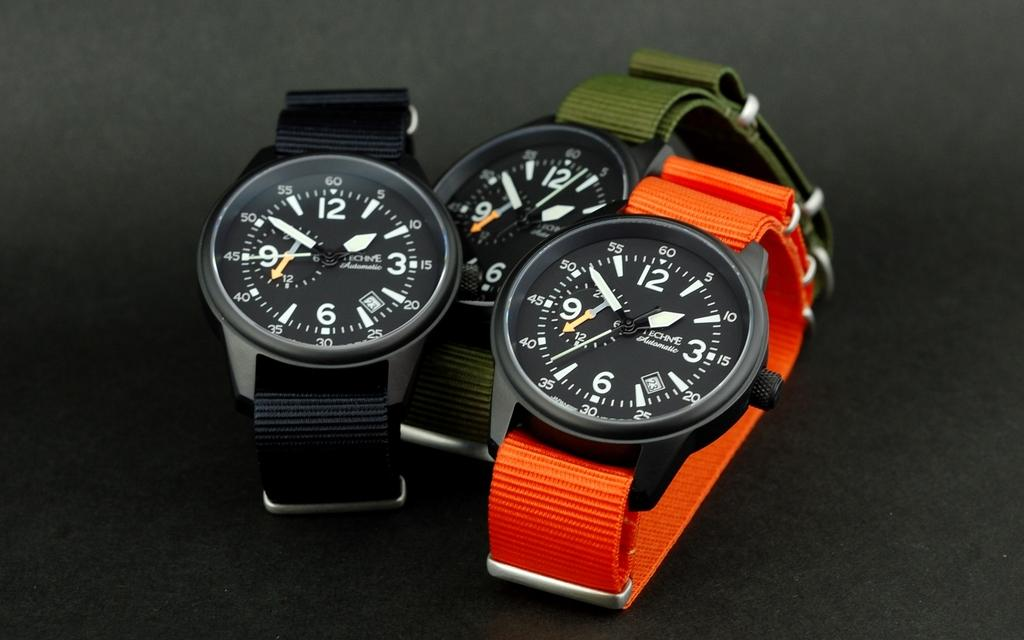How many watches are visible in the image? There are three watches in the image. What distinguishes the watches from one another? The watches have different colors. What can be seen on the faces of the watches? The watches have numbers on their faces. What features are present on the watches for measuring time? The watches have hour, minute, and second hands. What is the color of the background in the image? The background of the image is black. What type of weather condition is depicted in the image? There is no weather condition depicted in the image; it features three watches with a black background. What sound can be heard coming from the watches in the image? There is no sound coming from the watches in the image, as they are not functioning or making any noise. 